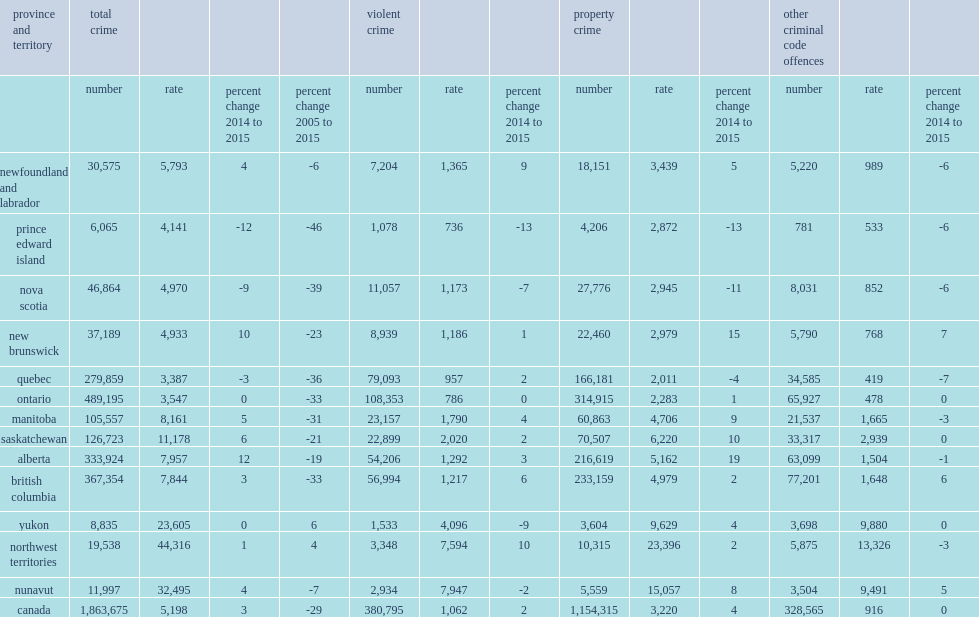The western provinces all reported relatively high csis and crime rates compared to the national csi in 2015, with saskatchewan continuing to record both the highest csi and crime rate (11,178 incidents per 100,000 population) among the provinces, what is the percentage of saskatchewan's crime rate? 11178.0. 